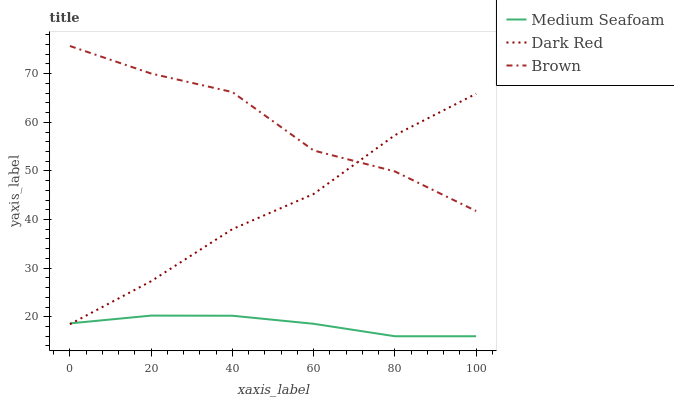Does Medium Seafoam have the minimum area under the curve?
Answer yes or no. Yes. Does Brown have the maximum area under the curve?
Answer yes or no. Yes. Does Brown have the minimum area under the curve?
Answer yes or no. No. Does Medium Seafoam have the maximum area under the curve?
Answer yes or no. No. Is Medium Seafoam the smoothest?
Answer yes or no. Yes. Is Brown the roughest?
Answer yes or no. Yes. Is Brown the smoothest?
Answer yes or no. No. Is Medium Seafoam the roughest?
Answer yes or no. No. Does Brown have the lowest value?
Answer yes or no. No. Does Brown have the highest value?
Answer yes or no. Yes. Does Medium Seafoam have the highest value?
Answer yes or no. No. Is Medium Seafoam less than Brown?
Answer yes or no. Yes. Is Brown greater than Medium Seafoam?
Answer yes or no. Yes. Does Brown intersect Dark Red?
Answer yes or no. Yes. Is Brown less than Dark Red?
Answer yes or no. No. Is Brown greater than Dark Red?
Answer yes or no. No. Does Medium Seafoam intersect Brown?
Answer yes or no. No. 